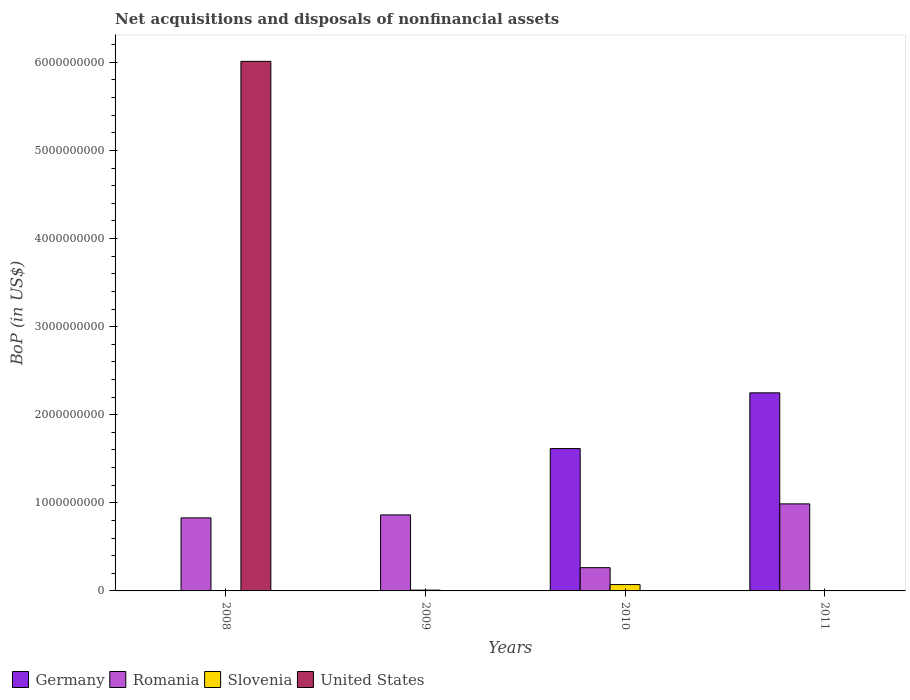How many different coloured bars are there?
Make the answer very short. 4. How many groups of bars are there?
Offer a terse response. 4. Are the number of bars per tick equal to the number of legend labels?
Provide a succinct answer. No. Are the number of bars on each tick of the X-axis equal?
Ensure brevity in your answer.  No. How many bars are there on the 3rd tick from the left?
Your response must be concise. 3. How many bars are there on the 1st tick from the right?
Ensure brevity in your answer.  2. What is the label of the 3rd group of bars from the left?
Ensure brevity in your answer.  2010. Across all years, what is the maximum Balance of Payments in Romania?
Ensure brevity in your answer.  9.88e+08. What is the total Balance of Payments in Germany in the graph?
Provide a succinct answer. 3.86e+09. What is the difference between the Balance of Payments in Germany in 2010 and that in 2011?
Ensure brevity in your answer.  -6.33e+08. What is the difference between the Balance of Payments in Romania in 2008 and the Balance of Payments in United States in 2010?
Your answer should be compact. 8.29e+08. What is the average Balance of Payments in United States per year?
Make the answer very short. 1.50e+09. In the year 2011, what is the difference between the Balance of Payments in Germany and Balance of Payments in Romania?
Provide a short and direct response. 1.26e+09. In how many years, is the Balance of Payments in United States greater than 4000000000 US$?
Offer a terse response. 1. What is the ratio of the Balance of Payments in Romania in 2009 to that in 2010?
Your response must be concise. 3.27. Is the Balance of Payments in Germany in 2010 less than that in 2011?
Your response must be concise. Yes. What is the difference between the highest and the second highest Balance of Payments in Romania?
Your answer should be very brief. 1.25e+08. What is the difference between the highest and the lowest Balance of Payments in Germany?
Offer a terse response. 2.25e+09. In how many years, is the Balance of Payments in United States greater than the average Balance of Payments in United States taken over all years?
Offer a very short reply. 1. Is it the case that in every year, the sum of the Balance of Payments in Slovenia and Balance of Payments in Romania is greater than the sum of Balance of Payments in United States and Balance of Payments in Germany?
Keep it short and to the point. No. Is it the case that in every year, the sum of the Balance of Payments in United States and Balance of Payments in Slovenia is greater than the Balance of Payments in Romania?
Keep it short and to the point. No. How many years are there in the graph?
Your answer should be compact. 4. What is the difference between two consecutive major ticks on the Y-axis?
Provide a succinct answer. 1.00e+09. Does the graph contain any zero values?
Offer a terse response. Yes. Does the graph contain grids?
Ensure brevity in your answer.  No. Where does the legend appear in the graph?
Offer a very short reply. Bottom left. How many legend labels are there?
Offer a terse response. 4. What is the title of the graph?
Your answer should be very brief. Net acquisitions and disposals of nonfinancial assets. What is the label or title of the Y-axis?
Keep it short and to the point. BoP (in US$). What is the BoP (in US$) in Romania in 2008?
Offer a terse response. 8.29e+08. What is the BoP (in US$) in Slovenia in 2008?
Give a very brief answer. 0. What is the BoP (in US$) in United States in 2008?
Keep it short and to the point. 6.01e+09. What is the BoP (in US$) of Romania in 2009?
Offer a very short reply. 8.63e+08. What is the BoP (in US$) of Slovenia in 2009?
Offer a very short reply. 9.16e+06. What is the BoP (in US$) of United States in 2009?
Ensure brevity in your answer.  0. What is the BoP (in US$) of Germany in 2010?
Give a very brief answer. 1.62e+09. What is the BoP (in US$) of Romania in 2010?
Provide a succinct answer. 2.64e+08. What is the BoP (in US$) of Slovenia in 2010?
Give a very brief answer. 7.20e+07. What is the BoP (in US$) in Germany in 2011?
Give a very brief answer. 2.25e+09. What is the BoP (in US$) of Romania in 2011?
Give a very brief answer. 9.88e+08. What is the BoP (in US$) in Slovenia in 2011?
Ensure brevity in your answer.  0. Across all years, what is the maximum BoP (in US$) of Germany?
Offer a terse response. 2.25e+09. Across all years, what is the maximum BoP (in US$) in Romania?
Your answer should be very brief. 9.88e+08. Across all years, what is the maximum BoP (in US$) in Slovenia?
Offer a very short reply. 7.20e+07. Across all years, what is the maximum BoP (in US$) in United States?
Give a very brief answer. 6.01e+09. Across all years, what is the minimum BoP (in US$) in Germany?
Provide a short and direct response. 0. Across all years, what is the minimum BoP (in US$) in Romania?
Keep it short and to the point. 2.64e+08. Across all years, what is the minimum BoP (in US$) of Slovenia?
Keep it short and to the point. 0. Across all years, what is the minimum BoP (in US$) of United States?
Your answer should be very brief. 0. What is the total BoP (in US$) in Germany in the graph?
Make the answer very short. 3.86e+09. What is the total BoP (in US$) in Romania in the graph?
Provide a short and direct response. 2.94e+09. What is the total BoP (in US$) in Slovenia in the graph?
Offer a very short reply. 8.12e+07. What is the total BoP (in US$) of United States in the graph?
Give a very brief answer. 6.01e+09. What is the difference between the BoP (in US$) of Romania in 2008 and that in 2009?
Give a very brief answer. -3.40e+07. What is the difference between the BoP (in US$) of Romania in 2008 and that in 2010?
Provide a succinct answer. 5.65e+08. What is the difference between the BoP (in US$) of Romania in 2008 and that in 2011?
Your answer should be compact. -1.59e+08. What is the difference between the BoP (in US$) in Romania in 2009 and that in 2010?
Give a very brief answer. 5.99e+08. What is the difference between the BoP (in US$) in Slovenia in 2009 and that in 2010?
Provide a short and direct response. -6.29e+07. What is the difference between the BoP (in US$) of Romania in 2009 and that in 2011?
Provide a succinct answer. -1.25e+08. What is the difference between the BoP (in US$) in Germany in 2010 and that in 2011?
Keep it short and to the point. -6.33e+08. What is the difference between the BoP (in US$) of Romania in 2010 and that in 2011?
Ensure brevity in your answer.  -7.24e+08. What is the difference between the BoP (in US$) of Romania in 2008 and the BoP (in US$) of Slovenia in 2009?
Your response must be concise. 8.20e+08. What is the difference between the BoP (in US$) of Romania in 2008 and the BoP (in US$) of Slovenia in 2010?
Your answer should be compact. 7.57e+08. What is the difference between the BoP (in US$) of Romania in 2009 and the BoP (in US$) of Slovenia in 2010?
Your answer should be compact. 7.91e+08. What is the difference between the BoP (in US$) in Germany in 2010 and the BoP (in US$) in Romania in 2011?
Make the answer very short. 6.28e+08. What is the average BoP (in US$) in Germany per year?
Provide a succinct answer. 9.66e+08. What is the average BoP (in US$) in Romania per year?
Your answer should be compact. 7.36e+08. What is the average BoP (in US$) of Slovenia per year?
Provide a short and direct response. 2.03e+07. What is the average BoP (in US$) in United States per year?
Your answer should be very brief. 1.50e+09. In the year 2008, what is the difference between the BoP (in US$) of Romania and BoP (in US$) of United States?
Your answer should be very brief. -5.18e+09. In the year 2009, what is the difference between the BoP (in US$) of Romania and BoP (in US$) of Slovenia?
Keep it short and to the point. 8.54e+08. In the year 2010, what is the difference between the BoP (in US$) of Germany and BoP (in US$) of Romania?
Give a very brief answer. 1.35e+09. In the year 2010, what is the difference between the BoP (in US$) in Germany and BoP (in US$) in Slovenia?
Offer a very short reply. 1.54e+09. In the year 2010, what is the difference between the BoP (in US$) of Romania and BoP (in US$) of Slovenia?
Provide a short and direct response. 1.92e+08. In the year 2011, what is the difference between the BoP (in US$) in Germany and BoP (in US$) in Romania?
Offer a very short reply. 1.26e+09. What is the ratio of the BoP (in US$) in Romania in 2008 to that in 2009?
Your answer should be very brief. 0.96. What is the ratio of the BoP (in US$) of Romania in 2008 to that in 2010?
Ensure brevity in your answer.  3.14. What is the ratio of the BoP (in US$) of Romania in 2008 to that in 2011?
Provide a succinct answer. 0.84. What is the ratio of the BoP (in US$) of Romania in 2009 to that in 2010?
Give a very brief answer. 3.27. What is the ratio of the BoP (in US$) of Slovenia in 2009 to that in 2010?
Offer a terse response. 0.13. What is the ratio of the BoP (in US$) of Romania in 2009 to that in 2011?
Offer a very short reply. 0.87. What is the ratio of the BoP (in US$) of Germany in 2010 to that in 2011?
Provide a short and direct response. 0.72. What is the ratio of the BoP (in US$) in Romania in 2010 to that in 2011?
Provide a short and direct response. 0.27. What is the difference between the highest and the second highest BoP (in US$) of Romania?
Offer a terse response. 1.25e+08. What is the difference between the highest and the lowest BoP (in US$) in Germany?
Offer a very short reply. 2.25e+09. What is the difference between the highest and the lowest BoP (in US$) in Romania?
Offer a terse response. 7.24e+08. What is the difference between the highest and the lowest BoP (in US$) of Slovenia?
Offer a very short reply. 7.20e+07. What is the difference between the highest and the lowest BoP (in US$) in United States?
Your answer should be compact. 6.01e+09. 